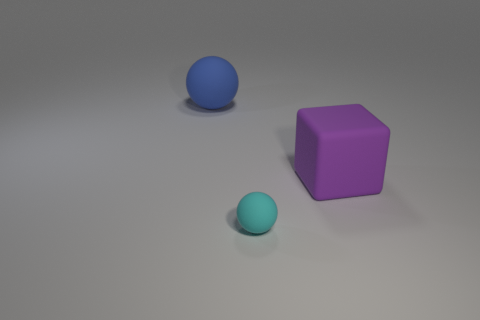Add 1 blue things. How many objects exist? 4 Subtract all blocks. How many objects are left? 2 Add 2 blue matte balls. How many blue matte balls exist? 3 Subtract 0 yellow spheres. How many objects are left? 3 Subtract all tiny cyan metallic spheres. Subtract all blue rubber balls. How many objects are left? 2 Add 2 purple things. How many purple things are left? 3 